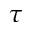Convert formula to latex. <formula><loc_0><loc_0><loc_500><loc_500>\tau</formula> 